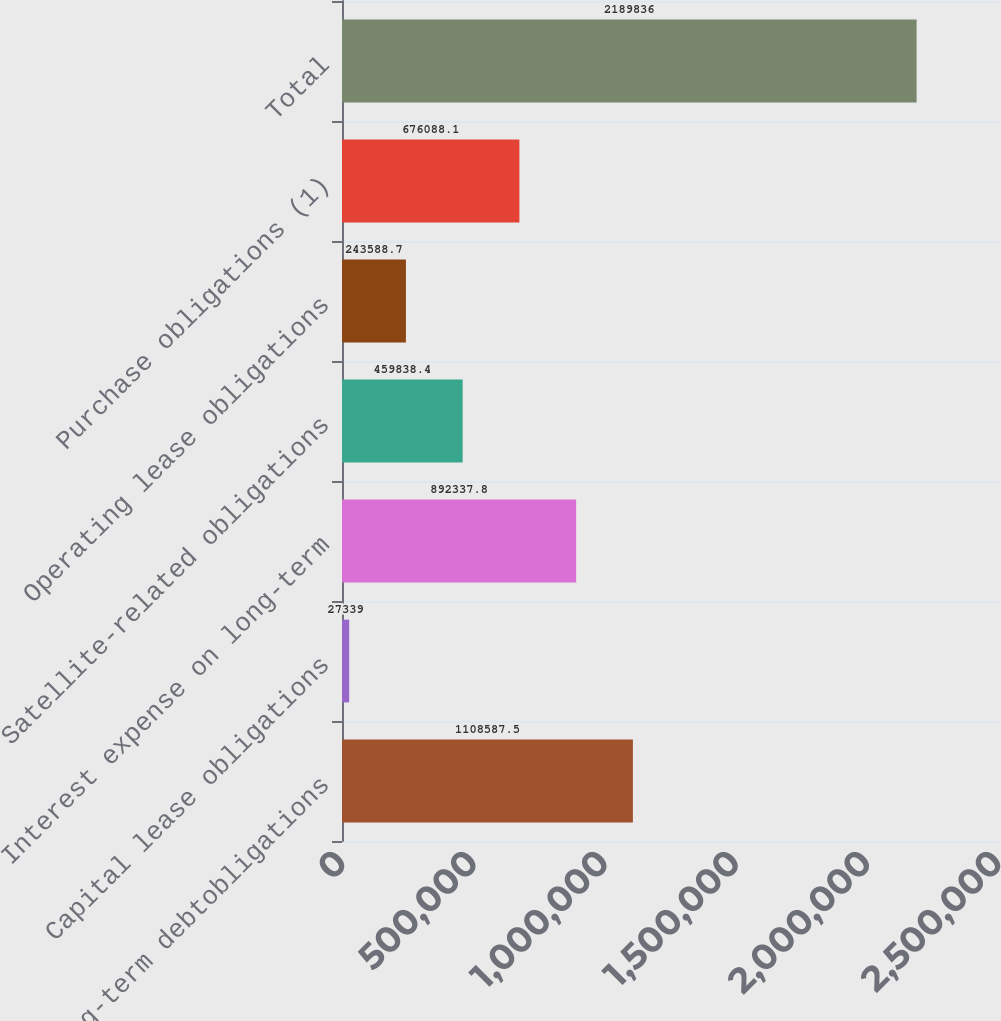Convert chart to OTSL. <chart><loc_0><loc_0><loc_500><loc_500><bar_chart><fcel>Long-term debtobligations<fcel>Capital lease obligations<fcel>Interest expense on long-term<fcel>Satellite-related obligations<fcel>Operating lease obligations<fcel>Purchase obligations (1)<fcel>Total<nl><fcel>1.10859e+06<fcel>27339<fcel>892338<fcel>459838<fcel>243589<fcel>676088<fcel>2.18984e+06<nl></chart> 